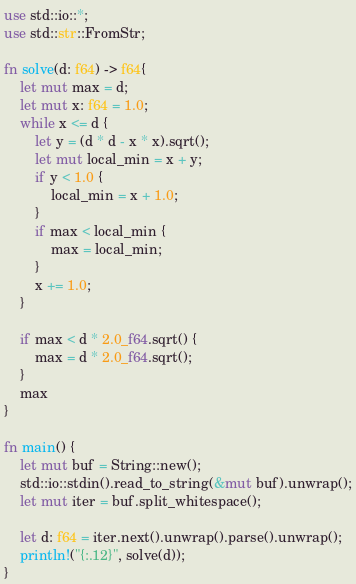Convert code to text. <code><loc_0><loc_0><loc_500><loc_500><_Rust_>use std::io::*;
use std::str::FromStr;

fn solve(d: f64) -> f64{
    let mut max = d;
    let mut x: f64 = 1.0;
    while x <= d {
        let y = (d * d - x * x).sqrt();
        let mut local_min = x + y;
        if y < 1.0 {
            local_min = x + 1.0;
        }
        if max < local_min {
            max = local_min;
        }
        x += 1.0;
    }

    if max < d * 2.0_f64.sqrt() {
        max = d * 2.0_f64.sqrt();
    }
    max
}

fn main() {
    let mut buf = String::new();
    std::io::stdin().read_to_string(&mut buf).unwrap();
    let mut iter = buf.split_whitespace();

    let d: f64 = iter.next().unwrap().parse().unwrap();
    println!("{:.12}", solve(d));
}

</code> 